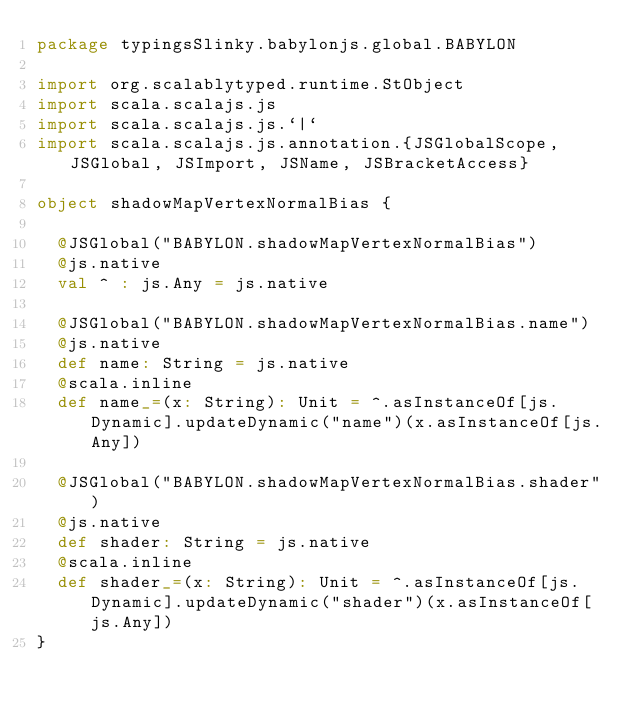<code> <loc_0><loc_0><loc_500><loc_500><_Scala_>package typingsSlinky.babylonjs.global.BABYLON

import org.scalablytyped.runtime.StObject
import scala.scalajs.js
import scala.scalajs.js.`|`
import scala.scalajs.js.annotation.{JSGlobalScope, JSGlobal, JSImport, JSName, JSBracketAccess}

object shadowMapVertexNormalBias {
  
  @JSGlobal("BABYLON.shadowMapVertexNormalBias")
  @js.native
  val ^ : js.Any = js.native
  
  @JSGlobal("BABYLON.shadowMapVertexNormalBias.name")
  @js.native
  def name: String = js.native
  @scala.inline
  def name_=(x: String): Unit = ^.asInstanceOf[js.Dynamic].updateDynamic("name")(x.asInstanceOf[js.Any])
  
  @JSGlobal("BABYLON.shadowMapVertexNormalBias.shader")
  @js.native
  def shader: String = js.native
  @scala.inline
  def shader_=(x: String): Unit = ^.asInstanceOf[js.Dynamic].updateDynamic("shader")(x.asInstanceOf[js.Any])
}
</code> 